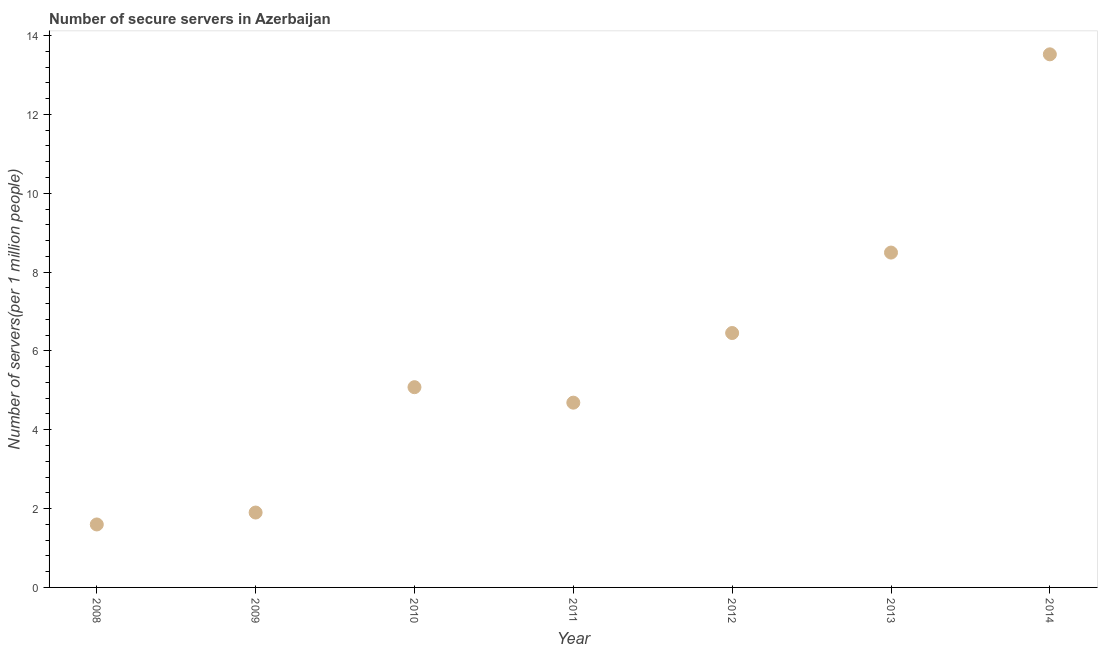What is the number of secure internet servers in 2010?
Offer a terse response. 5.08. Across all years, what is the maximum number of secure internet servers?
Give a very brief answer. 13.53. Across all years, what is the minimum number of secure internet servers?
Provide a succinct answer. 1.6. What is the sum of the number of secure internet servers?
Make the answer very short. 41.74. What is the difference between the number of secure internet servers in 2008 and 2011?
Give a very brief answer. -3.09. What is the average number of secure internet servers per year?
Your answer should be very brief. 5.96. What is the median number of secure internet servers?
Your response must be concise. 5.08. What is the ratio of the number of secure internet servers in 2008 to that in 2012?
Provide a succinct answer. 0.25. Is the difference between the number of secure internet servers in 2008 and 2010 greater than the difference between any two years?
Offer a very short reply. No. What is the difference between the highest and the second highest number of secure internet servers?
Offer a very short reply. 5.03. What is the difference between the highest and the lowest number of secure internet servers?
Provide a succinct answer. 11.93. In how many years, is the number of secure internet servers greater than the average number of secure internet servers taken over all years?
Provide a short and direct response. 3. How many dotlines are there?
Give a very brief answer. 1. Are the values on the major ticks of Y-axis written in scientific E-notation?
Make the answer very short. No. Does the graph contain any zero values?
Offer a very short reply. No. What is the title of the graph?
Offer a terse response. Number of secure servers in Azerbaijan. What is the label or title of the Y-axis?
Provide a succinct answer. Number of servers(per 1 million people). What is the Number of servers(per 1 million people) in 2008?
Your answer should be very brief. 1.6. What is the Number of servers(per 1 million people) in 2009?
Provide a succinct answer. 1.9. What is the Number of servers(per 1 million people) in 2010?
Offer a very short reply. 5.08. What is the Number of servers(per 1 million people) in 2011?
Provide a short and direct response. 4.69. What is the Number of servers(per 1 million people) in 2012?
Your answer should be compact. 6.45. What is the Number of servers(per 1 million people) in 2013?
Ensure brevity in your answer.  8.5. What is the Number of servers(per 1 million people) in 2014?
Offer a very short reply. 13.53. What is the difference between the Number of servers(per 1 million people) in 2008 and 2009?
Provide a succinct answer. -0.3. What is the difference between the Number of servers(per 1 million people) in 2008 and 2010?
Ensure brevity in your answer.  -3.48. What is the difference between the Number of servers(per 1 million people) in 2008 and 2011?
Ensure brevity in your answer.  -3.09. What is the difference between the Number of servers(per 1 million people) in 2008 and 2012?
Provide a short and direct response. -4.86. What is the difference between the Number of servers(per 1 million people) in 2008 and 2013?
Ensure brevity in your answer.  -6.9. What is the difference between the Number of servers(per 1 million people) in 2008 and 2014?
Make the answer very short. -11.93. What is the difference between the Number of servers(per 1 million people) in 2009 and 2010?
Give a very brief answer. -3.18. What is the difference between the Number of servers(per 1 million people) in 2009 and 2011?
Provide a short and direct response. -2.79. What is the difference between the Number of servers(per 1 million people) in 2009 and 2012?
Keep it short and to the point. -4.55. What is the difference between the Number of servers(per 1 million people) in 2009 and 2013?
Offer a terse response. -6.6. What is the difference between the Number of servers(per 1 million people) in 2009 and 2014?
Provide a succinct answer. -11.63. What is the difference between the Number of servers(per 1 million people) in 2010 and 2011?
Your answer should be very brief. 0.39. What is the difference between the Number of servers(per 1 million people) in 2010 and 2012?
Your answer should be very brief. -1.37. What is the difference between the Number of servers(per 1 million people) in 2010 and 2013?
Your answer should be very brief. -3.42. What is the difference between the Number of servers(per 1 million people) in 2010 and 2014?
Give a very brief answer. -8.44. What is the difference between the Number of servers(per 1 million people) in 2011 and 2012?
Offer a very short reply. -1.77. What is the difference between the Number of servers(per 1 million people) in 2011 and 2013?
Offer a terse response. -3.81. What is the difference between the Number of servers(per 1 million people) in 2011 and 2014?
Keep it short and to the point. -8.84. What is the difference between the Number of servers(per 1 million people) in 2012 and 2013?
Give a very brief answer. -2.04. What is the difference between the Number of servers(per 1 million people) in 2012 and 2014?
Provide a succinct answer. -7.07. What is the difference between the Number of servers(per 1 million people) in 2013 and 2014?
Provide a succinct answer. -5.03. What is the ratio of the Number of servers(per 1 million people) in 2008 to that in 2009?
Your response must be concise. 0.84. What is the ratio of the Number of servers(per 1 million people) in 2008 to that in 2010?
Give a very brief answer. 0.31. What is the ratio of the Number of servers(per 1 million people) in 2008 to that in 2011?
Your answer should be compact. 0.34. What is the ratio of the Number of servers(per 1 million people) in 2008 to that in 2012?
Offer a very short reply. 0.25. What is the ratio of the Number of servers(per 1 million people) in 2008 to that in 2013?
Your response must be concise. 0.19. What is the ratio of the Number of servers(per 1 million people) in 2008 to that in 2014?
Your answer should be compact. 0.12. What is the ratio of the Number of servers(per 1 million people) in 2009 to that in 2010?
Provide a succinct answer. 0.37. What is the ratio of the Number of servers(per 1 million people) in 2009 to that in 2011?
Offer a terse response. 0.41. What is the ratio of the Number of servers(per 1 million people) in 2009 to that in 2012?
Keep it short and to the point. 0.29. What is the ratio of the Number of servers(per 1 million people) in 2009 to that in 2013?
Offer a terse response. 0.22. What is the ratio of the Number of servers(per 1 million people) in 2009 to that in 2014?
Make the answer very short. 0.14. What is the ratio of the Number of servers(per 1 million people) in 2010 to that in 2011?
Provide a short and direct response. 1.08. What is the ratio of the Number of servers(per 1 million people) in 2010 to that in 2012?
Make the answer very short. 0.79. What is the ratio of the Number of servers(per 1 million people) in 2010 to that in 2013?
Keep it short and to the point. 0.6. What is the ratio of the Number of servers(per 1 million people) in 2010 to that in 2014?
Give a very brief answer. 0.38. What is the ratio of the Number of servers(per 1 million people) in 2011 to that in 2012?
Provide a succinct answer. 0.73. What is the ratio of the Number of servers(per 1 million people) in 2011 to that in 2013?
Your response must be concise. 0.55. What is the ratio of the Number of servers(per 1 million people) in 2011 to that in 2014?
Keep it short and to the point. 0.35. What is the ratio of the Number of servers(per 1 million people) in 2012 to that in 2013?
Ensure brevity in your answer.  0.76. What is the ratio of the Number of servers(per 1 million people) in 2012 to that in 2014?
Your answer should be compact. 0.48. What is the ratio of the Number of servers(per 1 million people) in 2013 to that in 2014?
Ensure brevity in your answer.  0.63. 